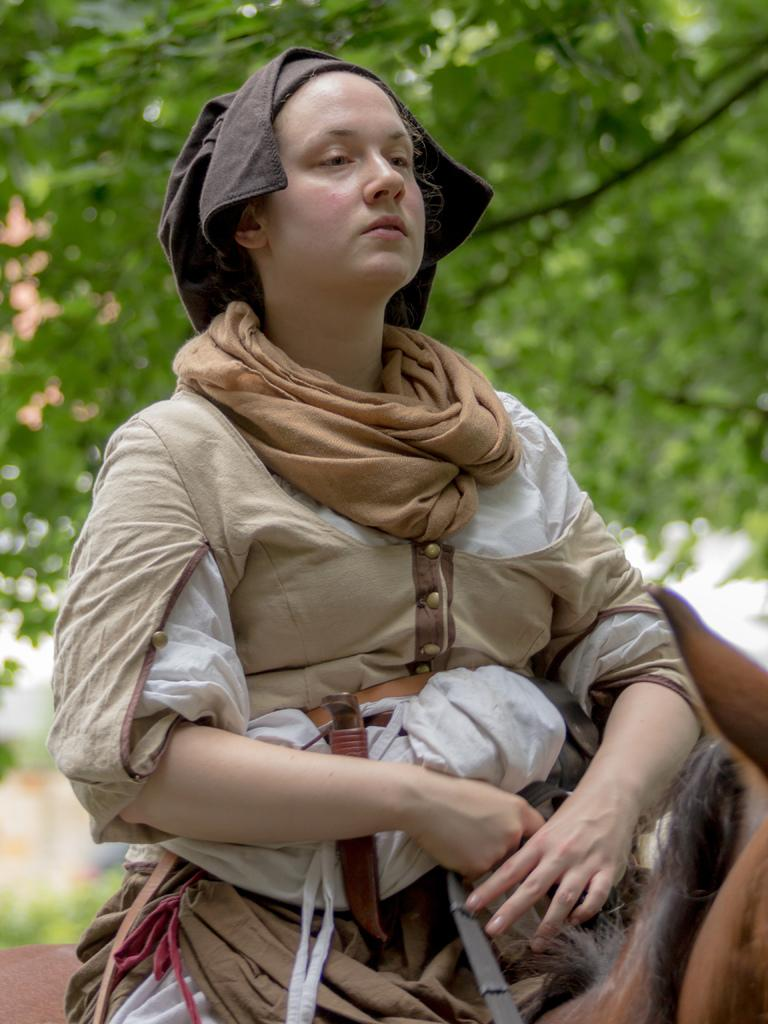Who is the main subject in the image? There is a woman in the image. What is the woman wearing? The woman is wearing clothes. What is the woman doing in the image? The woman is sitting on a horse. What can be seen in the background of the image? There is a tree visible in the background of the image. How is the background of the image depicted? The background is blurred. What type of sock is the woman wearing in the image? There is no sock visible in the image, as the woman is wearing clothes, but no specific mention of socks is made. 